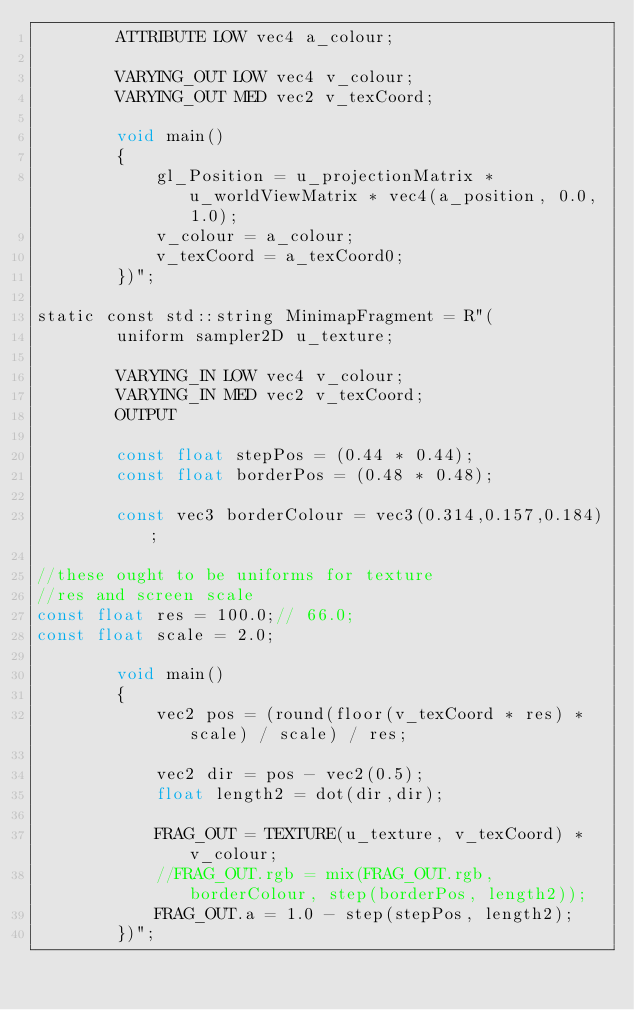Convert code to text. <code><loc_0><loc_0><loc_500><loc_500><_C++_>        ATTRIBUTE LOW vec4 a_colour;

        VARYING_OUT LOW vec4 v_colour;
        VARYING_OUT MED vec2 v_texCoord;

        void main()
        {
            gl_Position = u_projectionMatrix * u_worldViewMatrix * vec4(a_position, 0.0, 1.0);
            v_colour = a_colour;
            v_texCoord = a_texCoord0;
        })";

static const std::string MinimapFragment = R"(
        uniform sampler2D u_texture;

        VARYING_IN LOW vec4 v_colour;
        VARYING_IN MED vec2 v_texCoord;
        OUTPUT
        
        const float stepPos = (0.44 * 0.44);
        const float borderPos = (0.48 * 0.48);

        const vec3 borderColour = vec3(0.314,0.157,0.184);

//these ought to be uniforms for texture
//res and screen scale
const float res = 100.0;// 66.0;
const float scale = 2.0;

        void main()
        {
            vec2 pos = (round(floor(v_texCoord * res) * scale) / scale) / res;

            vec2 dir = pos - vec2(0.5);
            float length2 = dot(dir,dir);

            FRAG_OUT = TEXTURE(u_texture, v_texCoord) * v_colour;
            //FRAG_OUT.rgb = mix(FRAG_OUT.rgb, borderColour, step(borderPos, length2));
            FRAG_OUT.a = 1.0 - step(stepPos, length2);
        })";</code> 